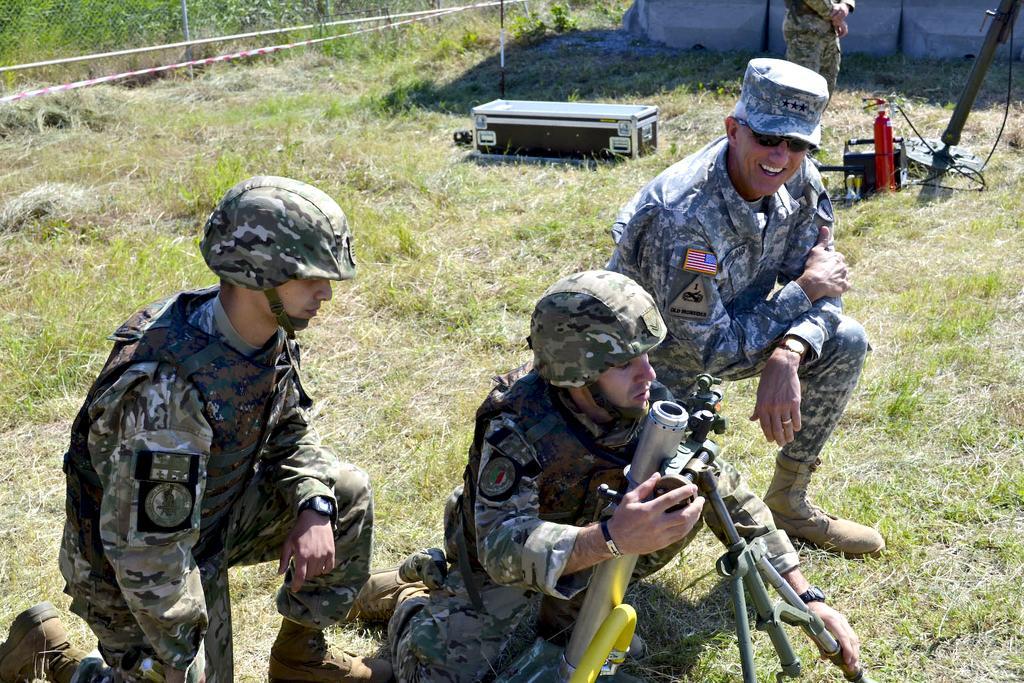Could you give a brief overview of what you see in this image? In this image at the bottom there are three persons who are sitting on their knees, and in the center there is one person who is holding some machine. At the bottom there is grass on the grass there is one box and some objects, in the background there is a fence and tent. 